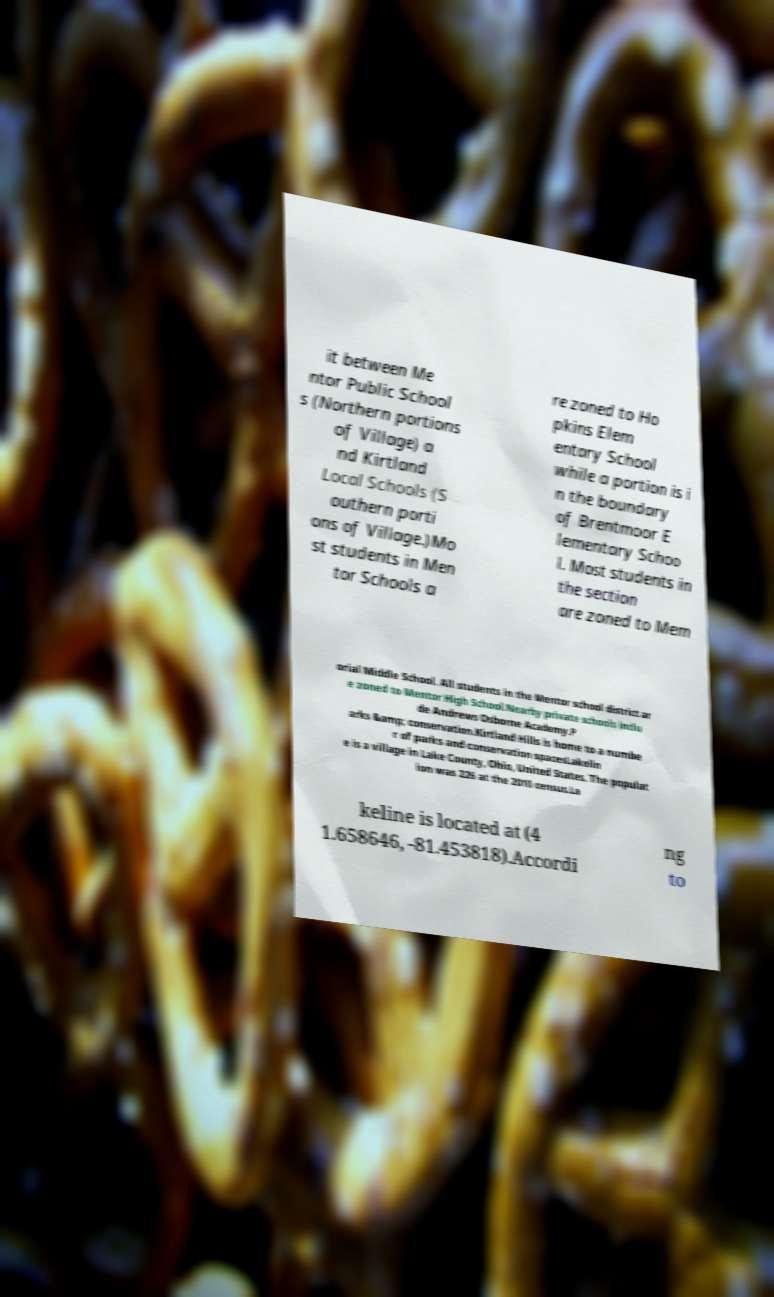What messages or text are displayed in this image? I need them in a readable, typed format. it between Me ntor Public School s (Northern portions of Village) a nd Kirtland Local Schools (S outhern porti ons of Village.)Mo st students in Men tor Schools a re zoned to Ho pkins Elem entary School while a portion is i n the boundary of Brentmoor E lementary Schoo l. Most students in the section are zoned to Mem orial Middle School. All students in the Mentor school district ar e zoned to Mentor High School.Nearby private schools inclu de Andrews Osborne Academy.P arks &amp; conservation.Kirtland Hills is home to a numbe r of parks and conservation spacesLakelin e is a village in Lake County, Ohio, United States. The populat ion was 226 at the 2010 census.La keline is located at (4 1.658646, -81.453818).Accordi ng to 